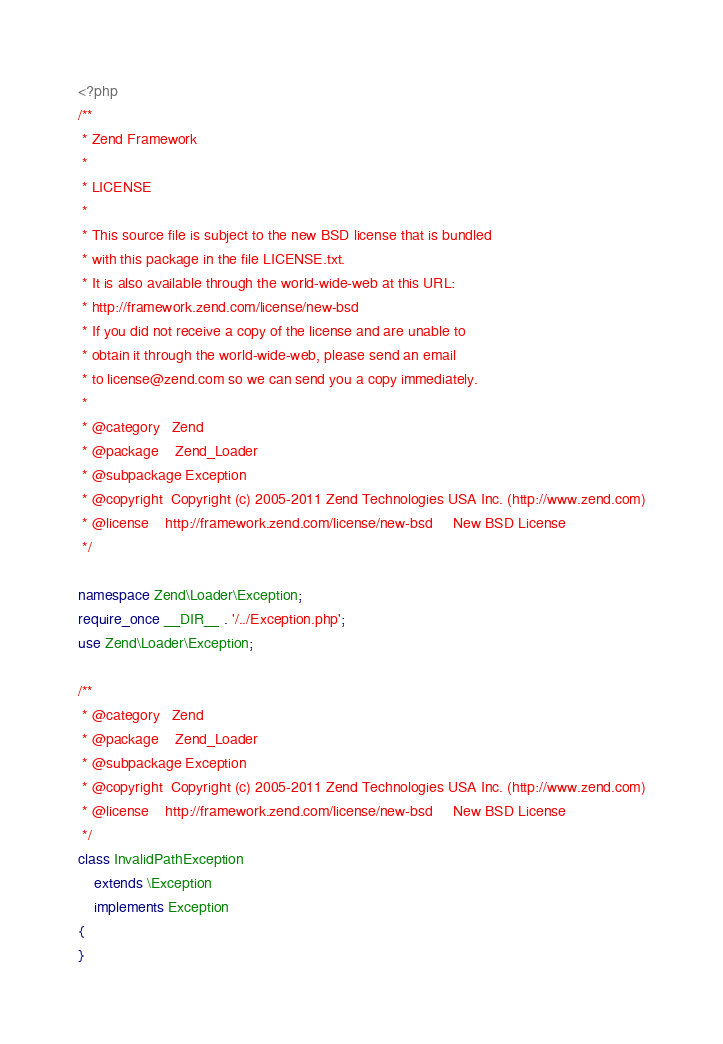<code> <loc_0><loc_0><loc_500><loc_500><_PHP_><?php
/**
 * Zend Framework
 *
 * LICENSE
 *
 * This source file is subject to the new BSD license that is bundled
 * with this package in the file LICENSE.txt.
 * It is also available through the world-wide-web at this URL:
 * http://framework.zend.com/license/new-bsd
 * If you did not receive a copy of the license and are unable to
 * obtain it through the world-wide-web, please send an email
 * to license@zend.com so we can send you a copy immediately.
 *
 * @category   Zend
 * @package    Zend_Loader
 * @subpackage Exception
 * @copyright  Copyright (c) 2005-2011 Zend Technologies USA Inc. (http://www.zend.com)
 * @license    http://framework.zend.com/license/new-bsd     New BSD License
 */

namespace Zend\Loader\Exception;
require_once __DIR__ . '/../Exception.php';
use Zend\Loader\Exception;

/**
 * @category   Zend
 * @package    Zend_Loader
 * @subpackage Exception
 * @copyright  Copyright (c) 2005-2011 Zend Technologies USA Inc. (http://www.zend.com)
 * @license    http://framework.zend.com/license/new-bsd     New BSD License
 */
class InvalidPathException
    extends \Exception
    implements Exception
{
}
</code> 